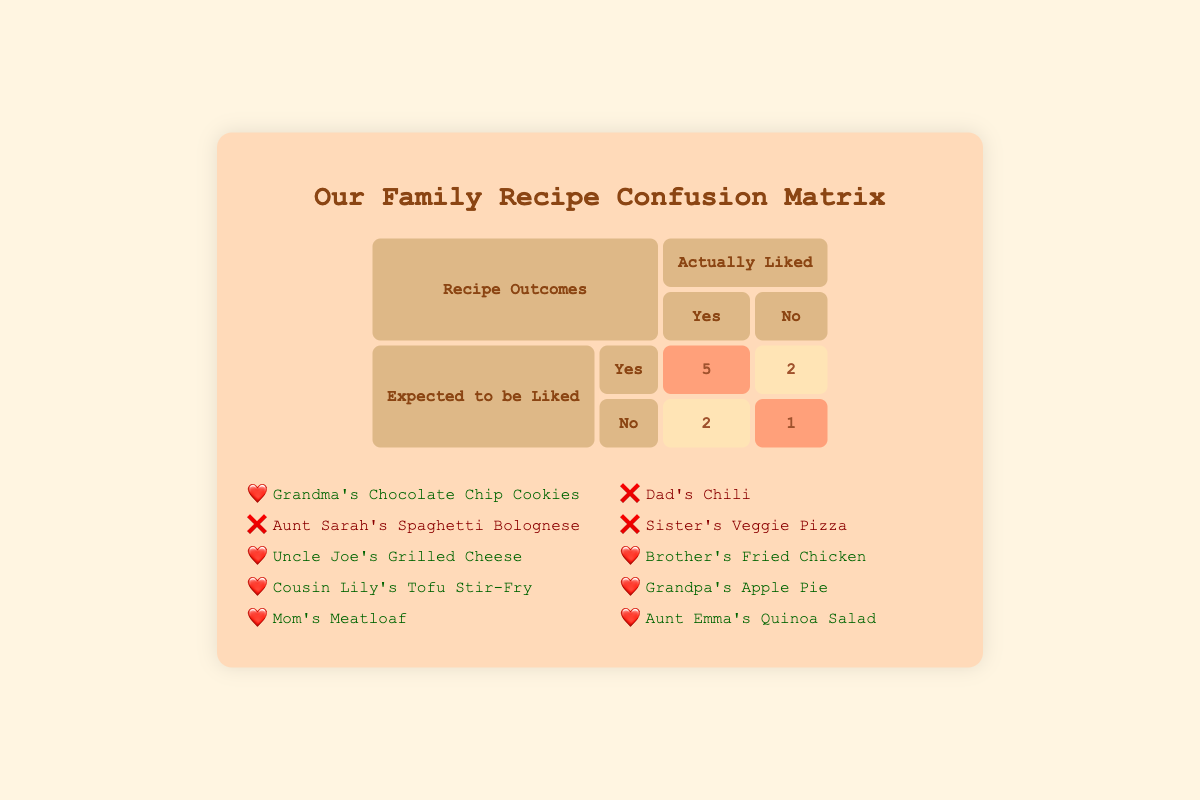What is the total number of recipes expected to be liked but disliked? In the confusion matrix, we look under the section "Expected to be Liked" and "No" for the actual liked column. Here, there are 2 recipes: Aunt Sarah's Spaghetti Bolognese and Dad's Chili.
Answer: 2 How many recipes did the family love that were actually liked? Under the "Expected to be Liked" for "Yes" in the "Actually Liked" column, there are 5 recipes that the family loved: Grandma's Chocolate Chip Cookies, Uncle Joe's Grilled Cheese, Mom's Meatloaf, Brother's Fried Chicken, and Grandpa's Apple Pie.
Answer: 5 Is there a recipe that was expected to be disliked but was actually liked? Yes, Cousin Lily's Tofu Stir-Fry was expected to be disliked but it was actually liked according to the matrix.
Answer: Yes What is the ratio of recipes that were liked to the total number of recipes? There are a total of 10 recipes, and 7 of them were actually liked (5 expected to be liked and 2 expected to be disliked but still liked). Thus, the ratio is 7 liked to 10 total which simplifies to 7:10.
Answer: 7:10 Which recipe had the greatest discrepancy between expected and actual liking? Aunt Sarah's Spaghetti Bolognese was expected to be liked but was actually disliked. This creates a discrepancy where it was expected to be received well, but it failed the expectations.
Answer: Aunt Sarah's Spaghetti Bolognese 